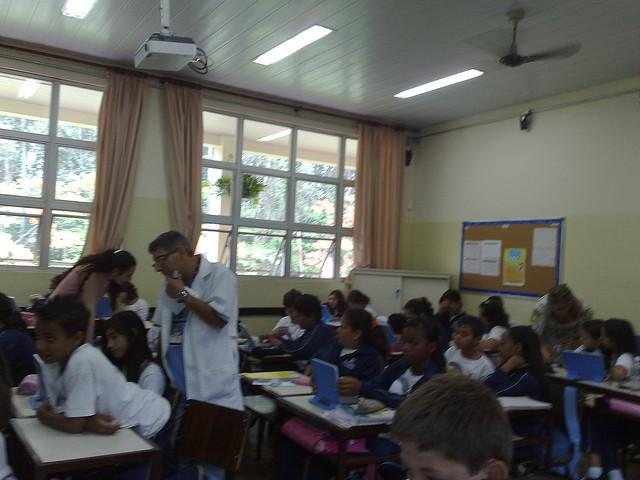What is the person in the white coat doing?

Choices:
A) shaving
B) taking vacation
C) having lunch
D) teaching teaching 